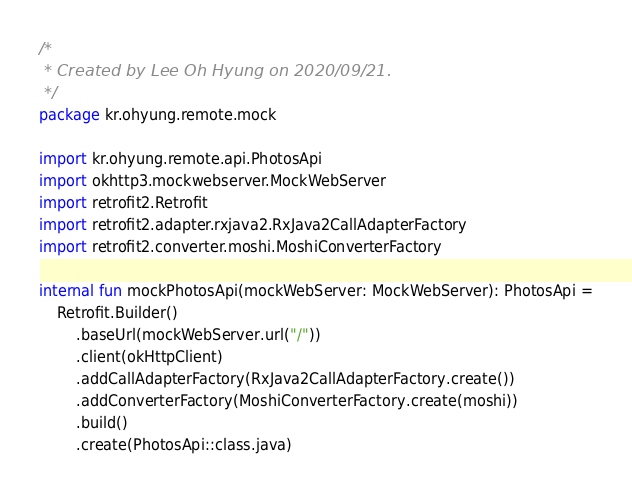Convert code to text. <code><loc_0><loc_0><loc_500><loc_500><_Kotlin_>/*
 * Created by Lee Oh Hyung on 2020/09/21.
 */
package kr.ohyung.remote.mock

import kr.ohyung.remote.api.PhotosApi
import okhttp3.mockwebserver.MockWebServer
import retrofit2.Retrofit
import retrofit2.adapter.rxjava2.RxJava2CallAdapterFactory
import retrofit2.converter.moshi.MoshiConverterFactory

internal fun mockPhotosApi(mockWebServer: MockWebServer): PhotosApi =
    Retrofit.Builder()
        .baseUrl(mockWebServer.url("/"))
        .client(okHttpClient)
        .addCallAdapterFactory(RxJava2CallAdapterFactory.create())
        .addConverterFactory(MoshiConverterFactory.create(moshi))
        .build()
        .create(PhotosApi::class.java)
</code> 